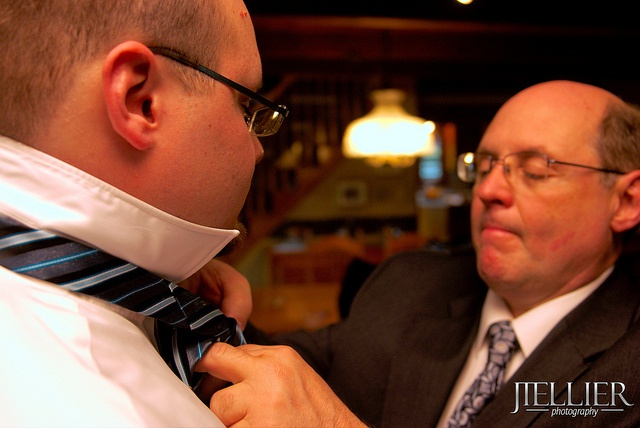Describe the objects in this image and their specific colors. I can see people in maroon, brown, white, and black tones, people in maroon, black, red, and salmon tones, tie in maroon, black, gray, and darkgray tones, and tie in maroon, gray, brown, and black tones in this image. 